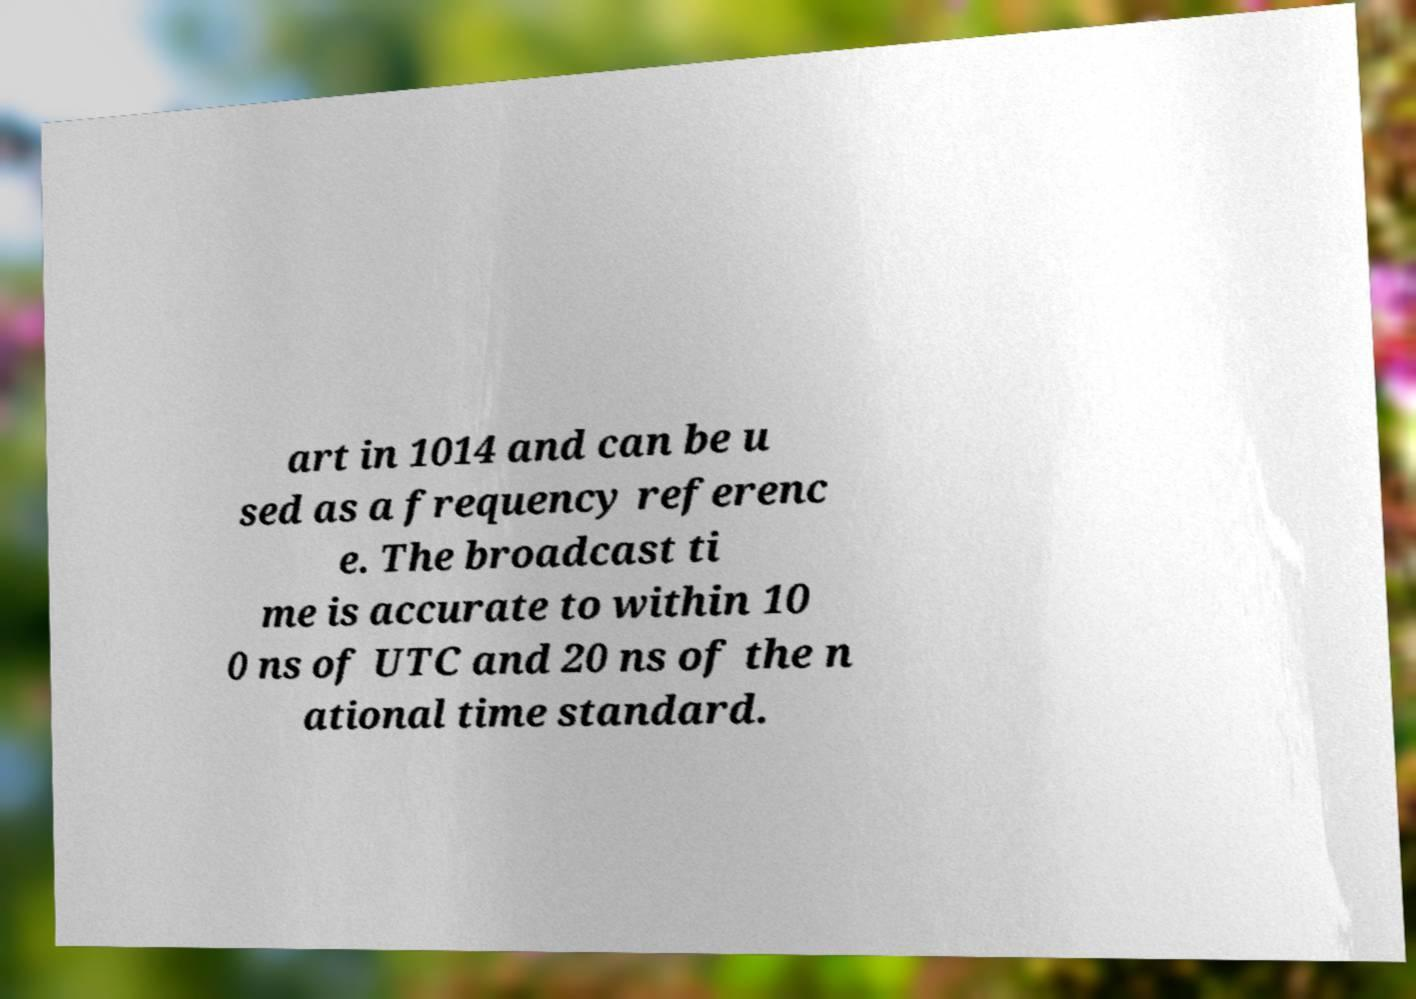I need the written content from this picture converted into text. Can you do that? art in 1014 and can be u sed as a frequency referenc e. The broadcast ti me is accurate to within 10 0 ns of UTC and 20 ns of the n ational time standard. 